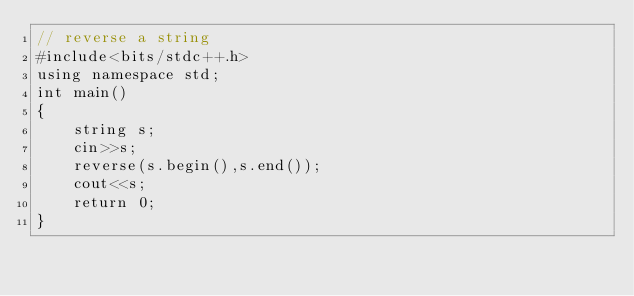<code> <loc_0><loc_0><loc_500><loc_500><_C++_>// reverse a string
#include<bits/stdc++.h>
using namespace std;
int main()
{
    string s;
    cin>>s;
    reverse(s.begin(),s.end());
    cout<<s;
    return 0;
}
</code> 